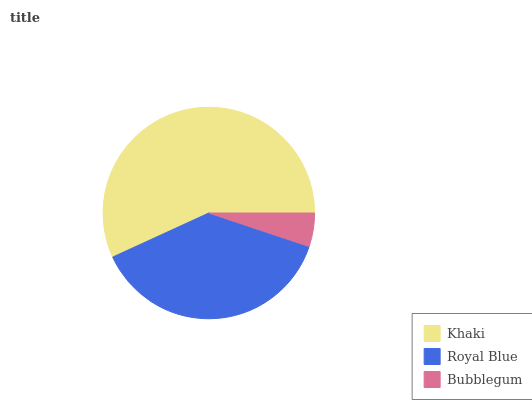Is Bubblegum the minimum?
Answer yes or no. Yes. Is Khaki the maximum?
Answer yes or no. Yes. Is Royal Blue the minimum?
Answer yes or no. No. Is Royal Blue the maximum?
Answer yes or no. No. Is Khaki greater than Royal Blue?
Answer yes or no. Yes. Is Royal Blue less than Khaki?
Answer yes or no. Yes. Is Royal Blue greater than Khaki?
Answer yes or no. No. Is Khaki less than Royal Blue?
Answer yes or no. No. Is Royal Blue the high median?
Answer yes or no. Yes. Is Royal Blue the low median?
Answer yes or no. Yes. Is Khaki the high median?
Answer yes or no. No. Is Bubblegum the low median?
Answer yes or no. No. 